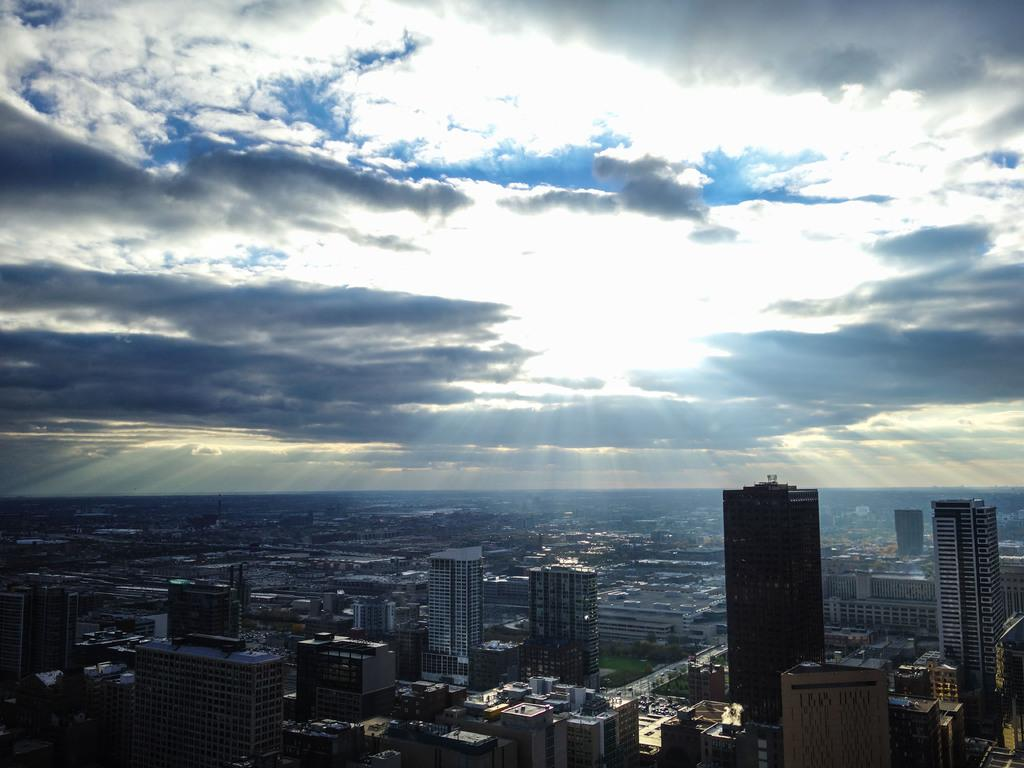What type of structures can be seen in the image? There are buildings in the image. What is the condition of the sky in the image? The sky is clear in the image. What can be observed in the sky in the image? Sun rays are visible in the image. What type of orange can be seen floating in the water in the image? There is no orange or water present in the image; it features buildings and a clear sky with sun rays. Is there a ship visible in the image? No, there is no ship present in the image. 